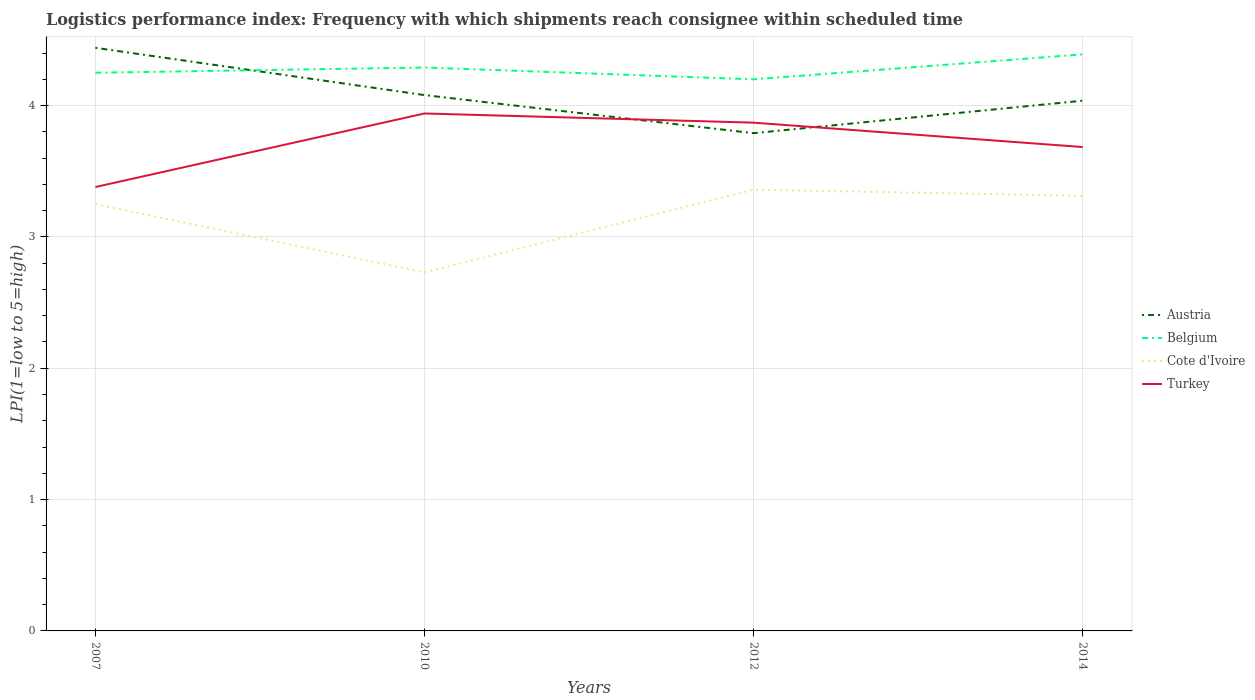How many different coloured lines are there?
Your answer should be compact. 4. Does the line corresponding to Belgium intersect with the line corresponding to Austria?
Your answer should be compact. Yes. Across all years, what is the maximum logistics performance index in Cote d'Ivoire?
Provide a succinct answer. 2.73. What is the total logistics performance index in Belgium in the graph?
Make the answer very short. -0.1. What is the difference between the highest and the second highest logistics performance index in Cote d'Ivoire?
Offer a terse response. 0.63. How many lines are there?
Give a very brief answer. 4. How many years are there in the graph?
Your answer should be very brief. 4. Are the values on the major ticks of Y-axis written in scientific E-notation?
Ensure brevity in your answer.  No. Does the graph contain any zero values?
Keep it short and to the point. No. Where does the legend appear in the graph?
Provide a succinct answer. Center right. How many legend labels are there?
Make the answer very short. 4. What is the title of the graph?
Give a very brief answer. Logistics performance index: Frequency with which shipments reach consignee within scheduled time. What is the label or title of the X-axis?
Your response must be concise. Years. What is the label or title of the Y-axis?
Provide a short and direct response. LPI(1=low to 5=high). What is the LPI(1=low to 5=high) of Austria in 2007?
Provide a succinct answer. 4.44. What is the LPI(1=low to 5=high) of Belgium in 2007?
Provide a succinct answer. 4.25. What is the LPI(1=low to 5=high) of Cote d'Ivoire in 2007?
Provide a short and direct response. 3.25. What is the LPI(1=low to 5=high) in Turkey in 2007?
Your answer should be compact. 3.38. What is the LPI(1=low to 5=high) of Austria in 2010?
Provide a succinct answer. 4.08. What is the LPI(1=low to 5=high) in Belgium in 2010?
Offer a very short reply. 4.29. What is the LPI(1=low to 5=high) in Cote d'Ivoire in 2010?
Offer a very short reply. 2.73. What is the LPI(1=low to 5=high) in Turkey in 2010?
Provide a short and direct response. 3.94. What is the LPI(1=low to 5=high) in Austria in 2012?
Make the answer very short. 3.79. What is the LPI(1=low to 5=high) of Belgium in 2012?
Give a very brief answer. 4.2. What is the LPI(1=low to 5=high) in Cote d'Ivoire in 2012?
Your response must be concise. 3.36. What is the LPI(1=low to 5=high) in Turkey in 2012?
Provide a succinct answer. 3.87. What is the LPI(1=low to 5=high) of Austria in 2014?
Give a very brief answer. 4.04. What is the LPI(1=low to 5=high) in Belgium in 2014?
Your response must be concise. 4.39. What is the LPI(1=low to 5=high) in Cote d'Ivoire in 2014?
Make the answer very short. 3.31. What is the LPI(1=low to 5=high) of Turkey in 2014?
Offer a very short reply. 3.68. Across all years, what is the maximum LPI(1=low to 5=high) of Austria?
Your answer should be very brief. 4.44. Across all years, what is the maximum LPI(1=low to 5=high) of Belgium?
Give a very brief answer. 4.39. Across all years, what is the maximum LPI(1=low to 5=high) of Cote d'Ivoire?
Provide a succinct answer. 3.36. Across all years, what is the maximum LPI(1=low to 5=high) in Turkey?
Your answer should be compact. 3.94. Across all years, what is the minimum LPI(1=low to 5=high) of Austria?
Your response must be concise. 3.79. Across all years, what is the minimum LPI(1=low to 5=high) in Cote d'Ivoire?
Make the answer very short. 2.73. Across all years, what is the minimum LPI(1=low to 5=high) of Turkey?
Give a very brief answer. 3.38. What is the total LPI(1=low to 5=high) in Austria in the graph?
Ensure brevity in your answer.  16.35. What is the total LPI(1=low to 5=high) in Belgium in the graph?
Your answer should be very brief. 17.13. What is the total LPI(1=low to 5=high) in Cote d'Ivoire in the graph?
Keep it short and to the point. 12.65. What is the total LPI(1=low to 5=high) in Turkey in the graph?
Provide a short and direct response. 14.87. What is the difference between the LPI(1=low to 5=high) of Austria in 2007 and that in 2010?
Give a very brief answer. 0.36. What is the difference between the LPI(1=low to 5=high) of Belgium in 2007 and that in 2010?
Offer a very short reply. -0.04. What is the difference between the LPI(1=low to 5=high) of Cote d'Ivoire in 2007 and that in 2010?
Your answer should be compact. 0.52. What is the difference between the LPI(1=low to 5=high) in Turkey in 2007 and that in 2010?
Provide a succinct answer. -0.56. What is the difference between the LPI(1=low to 5=high) of Austria in 2007 and that in 2012?
Keep it short and to the point. 0.65. What is the difference between the LPI(1=low to 5=high) of Cote d'Ivoire in 2007 and that in 2012?
Your answer should be compact. -0.11. What is the difference between the LPI(1=low to 5=high) in Turkey in 2007 and that in 2012?
Make the answer very short. -0.49. What is the difference between the LPI(1=low to 5=high) in Austria in 2007 and that in 2014?
Ensure brevity in your answer.  0.4. What is the difference between the LPI(1=low to 5=high) of Belgium in 2007 and that in 2014?
Your answer should be compact. -0.14. What is the difference between the LPI(1=low to 5=high) of Cote d'Ivoire in 2007 and that in 2014?
Your answer should be very brief. -0.06. What is the difference between the LPI(1=low to 5=high) in Turkey in 2007 and that in 2014?
Keep it short and to the point. -0.3. What is the difference between the LPI(1=low to 5=high) of Austria in 2010 and that in 2012?
Provide a succinct answer. 0.29. What is the difference between the LPI(1=low to 5=high) of Belgium in 2010 and that in 2012?
Your response must be concise. 0.09. What is the difference between the LPI(1=low to 5=high) of Cote d'Ivoire in 2010 and that in 2012?
Your answer should be very brief. -0.63. What is the difference between the LPI(1=low to 5=high) of Turkey in 2010 and that in 2012?
Your answer should be very brief. 0.07. What is the difference between the LPI(1=low to 5=high) in Austria in 2010 and that in 2014?
Give a very brief answer. 0.04. What is the difference between the LPI(1=low to 5=high) of Belgium in 2010 and that in 2014?
Your answer should be very brief. -0.1. What is the difference between the LPI(1=low to 5=high) in Cote d'Ivoire in 2010 and that in 2014?
Give a very brief answer. -0.58. What is the difference between the LPI(1=low to 5=high) of Turkey in 2010 and that in 2014?
Your response must be concise. 0.26. What is the difference between the LPI(1=low to 5=high) of Austria in 2012 and that in 2014?
Your response must be concise. -0.25. What is the difference between the LPI(1=low to 5=high) of Belgium in 2012 and that in 2014?
Keep it short and to the point. -0.19. What is the difference between the LPI(1=low to 5=high) in Cote d'Ivoire in 2012 and that in 2014?
Provide a short and direct response. 0.05. What is the difference between the LPI(1=low to 5=high) in Turkey in 2012 and that in 2014?
Provide a succinct answer. 0.19. What is the difference between the LPI(1=low to 5=high) in Austria in 2007 and the LPI(1=low to 5=high) in Cote d'Ivoire in 2010?
Your answer should be very brief. 1.71. What is the difference between the LPI(1=low to 5=high) of Austria in 2007 and the LPI(1=low to 5=high) of Turkey in 2010?
Offer a very short reply. 0.5. What is the difference between the LPI(1=low to 5=high) of Belgium in 2007 and the LPI(1=low to 5=high) of Cote d'Ivoire in 2010?
Your answer should be compact. 1.52. What is the difference between the LPI(1=low to 5=high) of Belgium in 2007 and the LPI(1=low to 5=high) of Turkey in 2010?
Give a very brief answer. 0.31. What is the difference between the LPI(1=low to 5=high) of Cote d'Ivoire in 2007 and the LPI(1=low to 5=high) of Turkey in 2010?
Your response must be concise. -0.69. What is the difference between the LPI(1=low to 5=high) in Austria in 2007 and the LPI(1=low to 5=high) in Belgium in 2012?
Keep it short and to the point. 0.24. What is the difference between the LPI(1=low to 5=high) of Austria in 2007 and the LPI(1=low to 5=high) of Turkey in 2012?
Offer a terse response. 0.57. What is the difference between the LPI(1=low to 5=high) of Belgium in 2007 and the LPI(1=low to 5=high) of Cote d'Ivoire in 2012?
Provide a succinct answer. 0.89. What is the difference between the LPI(1=low to 5=high) of Belgium in 2007 and the LPI(1=low to 5=high) of Turkey in 2012?
Your answer should be compact. 0.38. What is the difference between the LPI(1=low to 5=high) of Cote d'Ivoire in 2007 and the LPI(1=low to 5=high) of Turkey in 2012?
Make the answer very short. -0.62. What is the difference between the LPI(1=low to 5=high) of Austria in 2007 and the LPI(1=low to 5=high) of Belgium in 2014?
Keep it short and to the point. 0.05. What is the difference between the LPI(1=low to 5=high) in Austria in 2007 and the LPI(1=low to 5=high) in Cote d'Ivoire in 2014?
Provide a short and direct response. 1.13. What is the difference between the LPI(1=low to 5=high) of Austria in 2007 and the LPI(1=low to 5=high) of Turkey in 2014?
Your answer should be compact. 0.76. What is the difference between the LPI(1=low to 5=high) in Belgium in 2007 and the LPI(1=low to 5=high) in Cote d'Ivoire in 2014?
Provide a short and direct response. 0.94. What is the difference between the LPI(1=low to 5=high) in Belgium in 2007 and the LPI(1=low to 5=high) in Turkey in 2014?
Provide a succinct answer. 0.57. What is the difference between the LPI(1=low to 5=high) of Cote d'Ivoire in 2007 and the LPI(1=low to 5=high) of Turkey in 2014?
Keep it short and to the point. -0.43. What is the difference between the LPI(1=low to 5=high) in Austria in 2010 and the LPI(1=low to 5=high) in Belgium in 2012?
Your answer should be very brief. -0.12. What is the difference between the LPI(1=low to 5=high) in Austria in 2010 and the LPI(1=low to 5=high) in Cote d'Ivoire in 2012?
Your response must be concise. 0.72. What is the difference between the LPI(1=low to 5=high) in Austria in 2010 and the LPI(1=low to 5=high) in Turkey in 2012?
Your response must be concise. 0.21. What is the difference between the LPI(1=low to 5=high) of Belgium in 2010 and the LPI(1=low to 5=high) of Cote d'Ivoire in 2012?
Give a very brief answer. 0.93. What is the difference between the LPI(1=low to 5=high) of Belgium in 2010 and the LPI(1=low to 5=high) of Turkey in 2012?
Provide a short and direct response. 0.42. What is the difference between the LPI(1=low to 5=high) in Cote d'Ivoire in 2010 and the LPI(1=low to 5=high) in Turkey in 2012?
Offer a very short reply. -1.14. What is the difference between the LPI(1=low to 5=high) in Austria in 2010 and the LPI(1=low to 5=high) in Belgium in 2014?
Your response must be concise. -0.31. What is the difference between the LPI(1=low to 5=high) in Austria in 2010 and the LPI(1=low to 5=high) in Cote d'Ivoire in 2014?
Keep it short and to the point. 0.77. What is the difference between the LPI(1=low to 5=high) of Austria in 2010 and the LPI(1=low to 5=high) of Turkey in 2014?
Your response must be concise. 0.4. What is the difference between the LPI(1=low to 5=high) in Belgium in 2010 and the LPI(1=low to 5=high) in Cote d'Ivoire in 2014?
Provide a succinct answer. 0.98. What is the difference between the LPI(1=low to 5=high) of Belgium in 2010 and the LPI(1=low to 5=high) of Turkey in 2014?
Make the answer very short. 0.61. What is the difference between the LPI(1=low to 5=high) in Cote d'Ivoire in 2010 and the LPI(1=low to 5=high) in Turkey in 2014?
Provide a short and direct response. -0.95. What is the difference between the LPI(1=low to 5=high) of Austria in 2012 and the LPI(1=low to 5=high) of Belgium in 2014?
Give a very brief answer. -0.6. What is the difference between the LPI(1=low to 5=high) of Austria in 2012 and the LPI(1=low to 5=high) of Cote d'Ivoire in 2014?
Keep it short and to the point. 0.48. What is the difference between the LPI(1=low to 5=high) in Austria in 2012 and the LPI(1=low to 5=high) in Turkey in 2014?
Your response must be concise. 0.11. What is the difference between the LPI(1=low to 5=high) in Belgium in 2012 and the LPI(1=low to 5=high) in Cote d'Ivoire in 2014?
Keep it short and to the point. 0.89. What is the difference between the LPI(1=low to 5=high) in Belgium in 2012 and the LPI(1=low to 5=high) in Turkey in 2014?
Ensure brevity in your answer.  0.52. What is the difference between the LPI(1=low to 5=high) of Cote d'Ivoire in 2012 and the LPI(1=low to 5=high) of Turkey in 2014?
Provide a succinct answer. -0.32. What is the average LPI(1=low to 5=high) of Austria per year?
Give a very brief answer. 4.09. What is the average LPI(1=low to 5=high) in Belgium per year?
Your answer should be compact. 4.28. What is the average LPI(1=low to 5=high) of Cote d'Ivoire per year?
Your answer should be very brief. 3.16. What is the average LPI(1=low to 5=high) in Turkey per year?
Ensure brevity in your answer.  3.72. In the year 2007, what is the difference between the LPI(1=low to 5=high) of Austria and LPI(1=low to 5=high) of Belgium?
Provide a succinct answer. 0.19. In the year 2007, what is the difference between the LPI(1=low to 5=high) of Austria and LPI(1=low to 5=high) of Cote d'Ivoire?
Keep it short and to the point. 1.19. In the year 2007, what is the difference between the LPI(1=low to 5=high) in Austria and LPI(1=low to 5=high) in Turkey?
Keep it short and to the point. 1.06. In the year 2007, what is the difference between the LPI(1=low to 5=high) of Belgium and LPI(1=low to 5=high) of Turkey?
Your answer should be very brief. 0.87. In the year 2007, what is the difference between the LPI(1=low to 5=high) of Cote d'Ivoire and LPI(1=low to 5=high) of Turkey?
Give a very brief answer. -0.13. In the year 2010, what is the difference between the LPI(1=low to 5=high) in Austria and LPI(1=low to 5=high) in Belgium?
Give a very brief answer. -0.21. In the year 2010, what is the difference between the LPI(1=low to 5=high) in Austria and LPI(1=low to 5=high) in Cote d'Ivoire?
Your answer should be compact. 1.35. In the year 2010, what is the difference between the LPI(1=low to 5=high) in Austria and LPI(1=low to 5=high) in Turkey?
Provide a short and direct response. 0.14. In the year 2010, what is the difference between the LPI(1=low to 5=high) of Belgium and LPI(1=low to 5=high) of Cote d'Ivoire?
Give a very brief answer. 1.56. In the year 2010, what is the difference between the LPI(1=low to 5=high) of Cote d'Ivoire and LPI(1=low to 5=high) of Turkey?
Give a very brief answer. -1.21. In the year 2012, what is the difference between the LPI(1=low to 5=high) in Austria and LPI(1=low to 5=high) in Belgium?
Offer a terse response. -0.41. In the year 2012, what is the difference between the LPI(1=low to 5=high) of Austria and LPI(1=low to 5=high) of Cote d'Ivoire?
Your answer should be very brief. 0.43. In the year 2012, what is the difference between the LPI(1=low to 5=high) in Austria and LPI(1=low to 5=high) in Turkey?
Your answer should be compact. -0.08. In the year 2012, what is the difference between the LPI(1=low to 5=high) in Belgium and LPI(1=low to 5=high) in Cote d'Ivoire?
Keep it short and to the point. 0.84. In the year 2012, what is the difference between the LPI(1=low to 5=high) in Belgium and LPI(1=low to 5=high) in Turkey?
Your response must be concise. 0.33. In the year 2012, what is the difference between the LPI(1=low to 5=high) in Cote d'Ivoire and LPI(1=low to 5=high) in Turkey?
Your answer should be compact. -0.51. In the year 2014, what is the difference between the LPI(1=low to 5=high) in Austria and LPI(1=low to 5=high) in Belgium?
Make the answer very short. -0.35. In the year 2014, what is the difference between the LPI(1=low to 5=high) of Austria and LPI(1=low to 5=high) of Cote d'Ivoire?
Make the answer very short. 0.72. In the year 2014, what is the difference between the LPI(1=low to 5=high) in Austria and LPI(1=low to 5=high) in Turkey?
Offer a very short reply. 0.35. In the year 2014, what is the difference between the LPI(1=low to 5=high) of Belgium and LPI(1=low to 5=high) of Turkey?
Give a very brief answer. 0.71. In the year 2014, what is the difference between the LPI(1=low to 5=high) of Cote d'Ivoire and LPI(1=low to 5=high) of Turkey?
Make the answer very short. -0.37. What is the ratio of the LPI(1=low to 5=high) in Austria in 2007 to that in 2010?
Offer a very short reply. 1.09. What is the ratio of the LPI(1=low to 5=high) of Belgium in 2007 to that in 2010?
Make the answer very short. 0.99. What is the ratio of the LPI(1=low to 5=high) of Cote d'Ivoire in 2007 to that in 2010?
Ensure brevity in your answer.  1.19. What is the ratio of the LPI(1=low to 5=high) in Turkey in 2007 to that in 2010?
Your answer should be very brief. 0.86. What is the ratio of the LPI(1=low to 5=high) of Austria in 2007 to that in 2012?
Give a very brief answer. 1.17. What is the ratio of the LPI(1=low to 5=high) in Belgium in 2007 to that in 2012?
Offer a very short reply. 1.01. What is the ratio of the LPI(1=low to 5=high) of Cote d'Ivoire in 2007 to that in 2012?
Your answer should be compact. 0.97. What is the ratio of the LPI(1=low to 5=high) of Turkey in 2007 to that in 2012?
Offer a very short reply. 0.87. What is the ratio of the LPI(1=low to 5=high) of Austria in 2007 to that in 2014?
Your answer should be compact. 1.1. What is the ratio of the LPI(1=low to 5=high) of Belgium in 2007 to that in 2014?
Offer a terse response. 0.97. What is the ratio of the LPI(1=low to 5=high) in Cote d'Ivoire in 2007 to that in 2014?
Offer a very short reply. 0.98. What is the ratio of the LPI(1=low to 5=high) of Turkey in 2007 to that in 2014?
Keep it short and to the point. 0.92. What is the ratio of the LPI(1=low to 5=high) in Austria in 2010 to that in 2012?
Your answer should be very brief. 1.08. What is the ratio of the LPI(1=low to 5=high) in Belgium in 2010 to that in 2012?
Your answer should be very brief. 1.02. What is the ratio of the LPI(1=low to 5=high) of Cote d'Ivoire in 2010 to that in 2012?
Your answer should be very brief. 0.81. What is the ratio of the LPI(1=low to 5=high) in Turkey in 2010 to that in 2012?
Provide a succinct answer. 1.02. What is the ratio of the LPI(1=low to 5=high) of Austria in 2010 to that in 2014?
Provide a succinct answer. 1.01. What is the ratio of the LPI(1=low to 5=high) in Belgium in 2010 to that in 2014?
Keep it short and to the point. 0.98. What is the ratio of the LPI(1=low to 5=high) of Cote d'Ivoire in 2010 to that in 2014?
Give a very brief answer. 0.82. What is the ratio of the LPI(1=low to 5=high) in Turkey in 2010 to that in 2014?
Your response must be concise. 1.07. What is the ratio of the LPI(1=low to 5=high) in Austria in 2012 to that in 2014?
Your response must be concise. 0.94. What is the ratio of the LPI(1=low to 5=high) of Belgium in 2012 to that in 2014?
Provide a short and direct response. 0.96. What is the ratio of the LPI(1=low to 5=high) of Cote d'Ivoire in 2012 to that in 2014?
Provide a short and direct response. 1.01. What is the ratio of the LPI(1=low to 5=high) of Turkey in 2012 to that in 2014?
Offer a very short reply. 1.05. What is the difference between the highest and the second highest LPI(1=low to 5=high) in Austria?
Your answer should be very brief. 0.36. What is the difference between the highest and the second highest LPI(1=low to 5=high) in Belgium?
Your response must be concise. 0.1. What is the difference between the highest and the second highest LPI(1=low to 5=high) of Cote d'Ivoire?
Your response must be concise. 0.05. What is the difference between the highest and the second highest LPI(1=low to 5=high) in Turkey?
Offer a very short reply. 0.07. What is the difference between the highest and the lowest LPI(1=low to 5=high) of Austria?
Offer a very short reply. 0.65. What is the difference between the highest and the lowest LPI(1=low to 5=high) in Belgium?
Keep it short and to the point. 0.19. What is the difference between the highest and the lowest LPI(1=low to 5=high) in Cote d'Ivoire?
Give a very brief answer. 0.63. What is the difference between the highest and the lowest LPI(1=low to 5=high) in Turkey?
Provide a short and direct response. 0.56. 